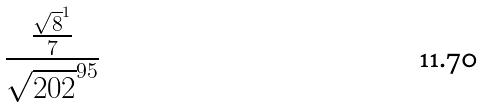Convert formula to latex. <formula><loc_0><loc_0><loc_500><loc_500>\frac { \frac { \sqrt { 8 } ^ { 1 } } { 7 } } { \sqrt { 2 0 2 } ^ { 9 5 } }</formula> 